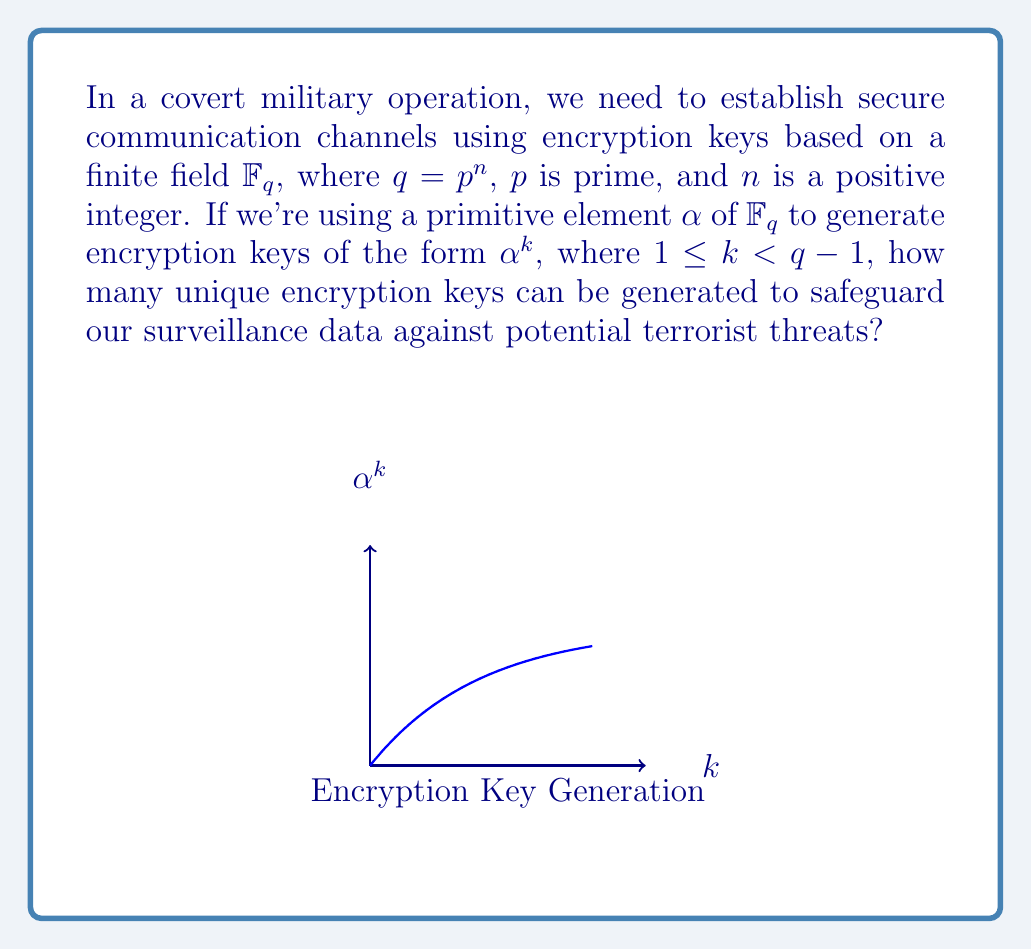Could you help me with this problem? Let's approach this step-by-step:

1) In a finite field $\mathbb{F}_q$, where $q = p^n$, there are $q$ elements in total.

2) A primitive element $\alpha$ of $\mathbb{F}_q$ has order $q-1$, meaning:
   $$\alpha^{q-1} = 1$$
   and $\alpha^k \neq 1$ for any $1 \leq k < q-1$

3) The powers of $\alpha$ generate all non-zero elements of $\mathbb{F}_q$:
   $$\{\alpha^1, \alpha^2, \alpha^3, ..., \alpha^{q-1} = 1\}$$

4) Since we're using keys of the form $\alpha^k$ where $1 \leq k < q-1$, we exclude $\alpha^{q-1} = 1$.

5) Therefore, the number of unique encryption keys is equal to the number of non-zero elements in $\mathbb{F}_q$ minus 1:
   $$(q - 1) - 1 = q - 2$$

6) Substituting $q = p^n$, we get:
   $$p^n - 2$$

This gives us the number of unique encryption keys that can be generated using the primitive element $\alpha$ in our finite field $\mathbb{F}_q$.
Answer: $p^n - 2$ 